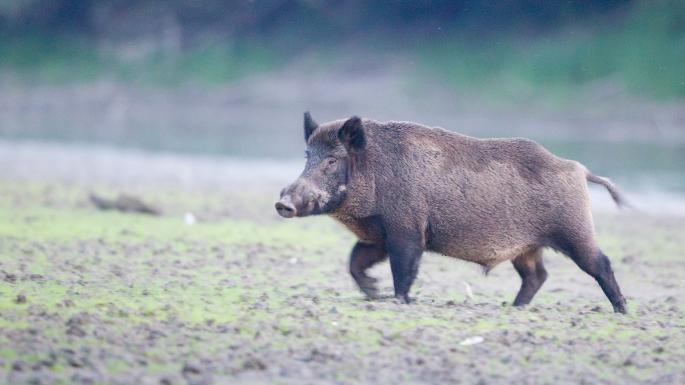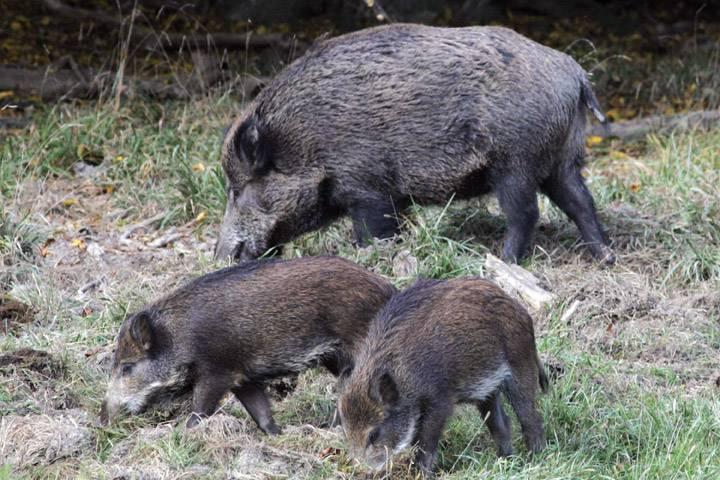The first image is the image on the left, the second image is the image on the right. Analyze the images presented: Is the assertion "There are two hogs in the pair of images ,both facing each other." valid? Answer yes or no. No. The first image is the image on the left, the second image is the image on the right. Analyze the images presented: Is the assertion "Each image contains a single wild pig, and the pigs in the right and left images appear to be facing each other." valid? Answer yes or no. No. 